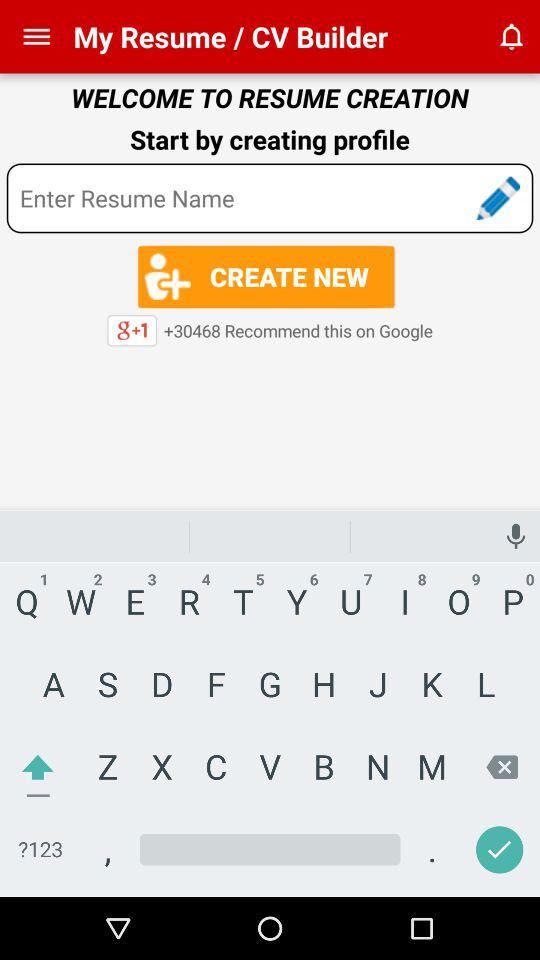How many users recommend this on Google? The number of users who recommended this on Google is 30468. 